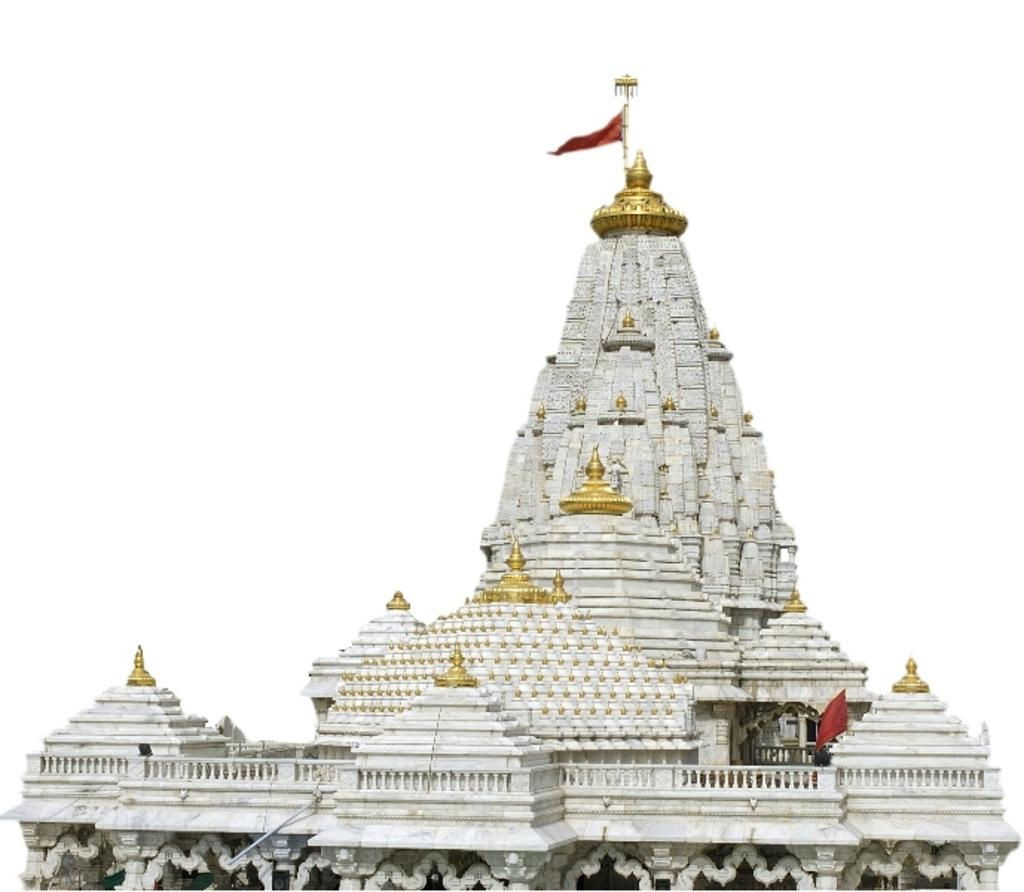What type of structure is present in the image? There is a temple in the image. What type of grape is being used as a decoration on the temple in the image? There is no grape present in the image, as it only features a temple. 